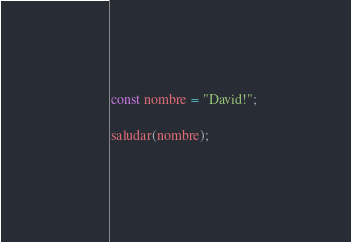<code> <loc_0><loc_0><loc_500><loc_500><_JavaScript_>
const nombre = "David!";

saludar(nombre);</code> 